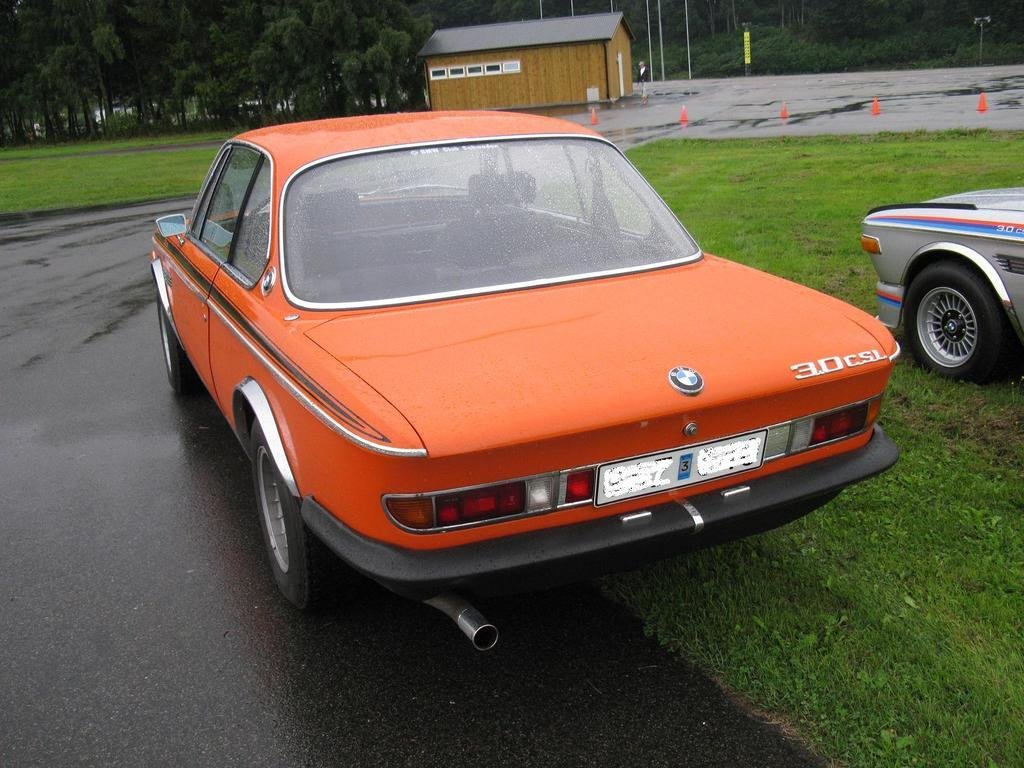What is the main subject of the image? The main subject of the image is cars on the grass. What can be seen in the background of the image? In the background of the image, there are road divider cones, a house, trees, and metal rods. What type of objects are present in the background of the image? The objects in the background include road divider cones, a house, trees, and metal rods. How much wealth does the beggar in the image possess? There is no beggar present in the image, so it is not possible to determine their wealth. 